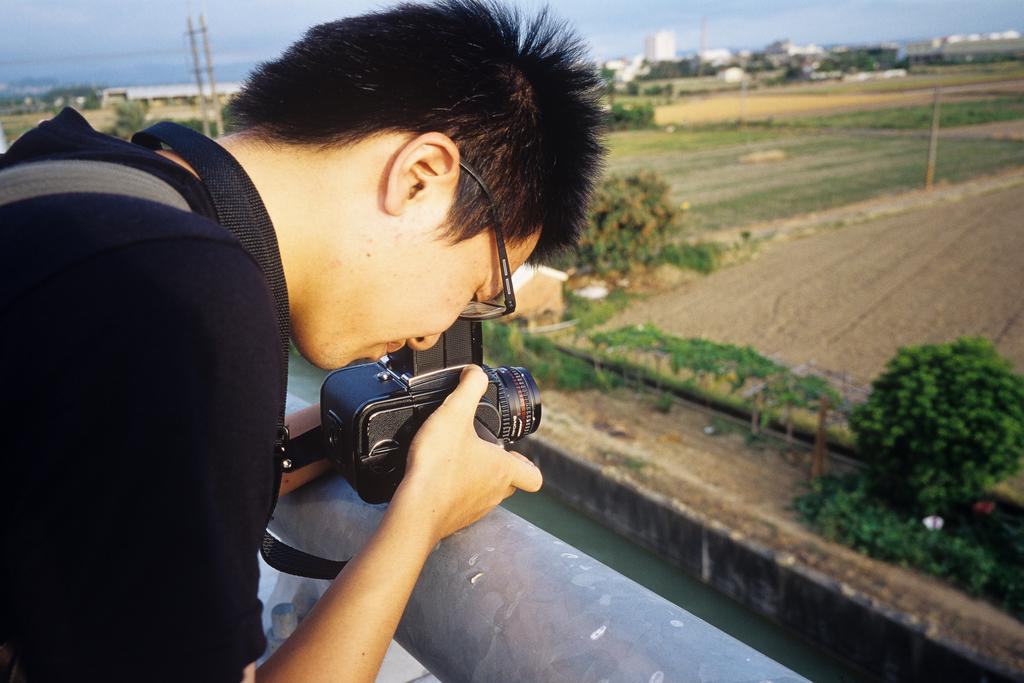What is the main subject of the image? There is a man in the image. What is the man doing in the image? The man is standing and looking at the camera. What is the man holding in his hand? The camera is in the man's hand. What can be seen in front of the man? There are farms, trees, water, buildings, and a pole in front of the man. What part of the natural environment is visible in the image? The sky is visible in the image. What type of drug is the man taking in the image? There is no indication in the image that the man is taking any drug. What effect does the drug have on the man in the image? Since there is no drug present in the image, it is impossible to determine any effects on the man. 